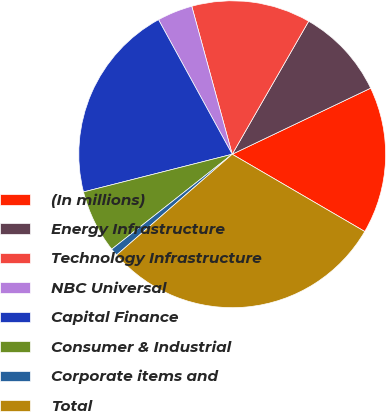Convert chart to OTSL. <chart><loc_0><loc_0><loc_500><loc_500><pie_chart><fcel>(In millions)<fcel>Energy Infrastructure<fcel>Technology Infrastructure<fcel>NBC Universal<fcel>Capital Finance<fcel>Consumer & Industrial<fcel>Corporate items and<fcel>Total<nl><fcel>15.49%<fcel>9.61%<fcel>12.55%<fcel>3.73%<fcel>20.98%<fcel>6.67%<fcel>0.79%<fcel>30.19%<nl></chart> 